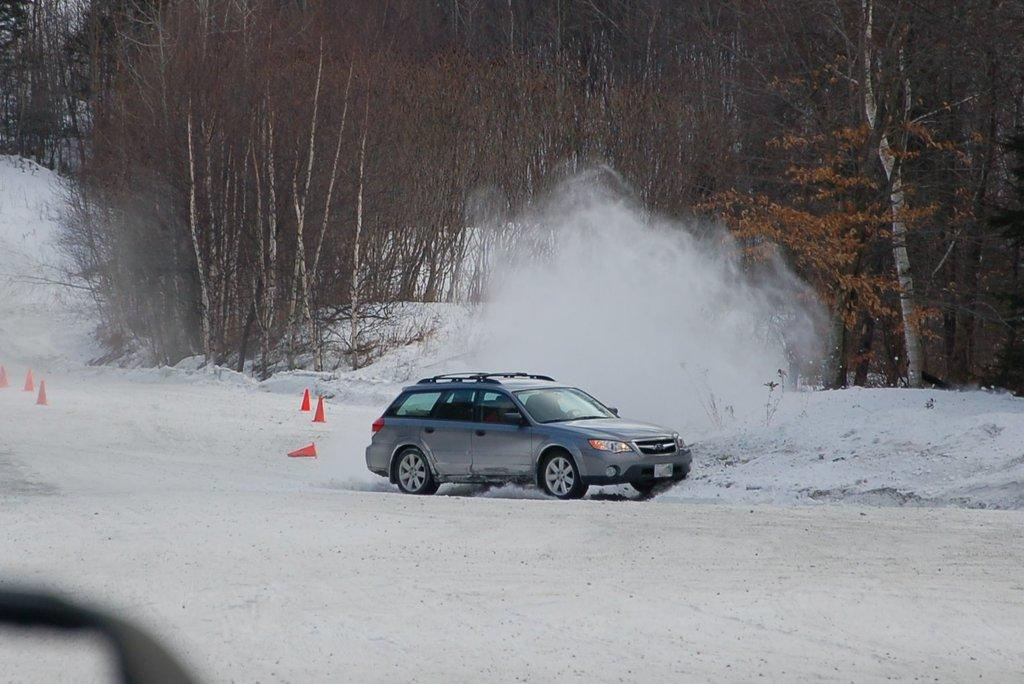What is the main subject in the center of the image? There is a car in the center of the image. What can be seen in the background of the image? There are trees in the background of the image. What is the condition of the ground in the image? There is snow on the ground in the image. How many eyes can be seen on the car in the image? Cars do not have eyes, so there are no eyes visible on the car in the image. Can you describe the cow that is jumping over the car in the image? There is no cow present in the image, nor is there any indication of a cow jumping over the car. 